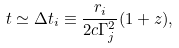<formula> <loc_0><loc_0><loc_500><loc_500>t \simeq \Delta t _ { i } \equiv \frac { r _ { i } } { 2 c \Gamma _ { j } ^ { 2 } } ( 1 + z ) ,</formula> 